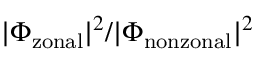<formula> <loc_0><loc_0><loc_500><loc_500>| \Phi _ { z o n a l } | ^ { 2 } / | \Phi _ { n o n z o n a l } | ^ { 2 }</formula> 